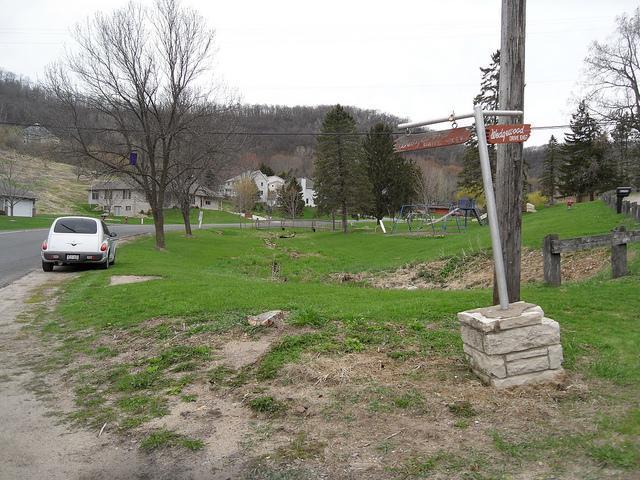How many cars are there?
Give a very brief answer. 1. How many large bags is the old man holding?
Give a very brief answer. 0. 